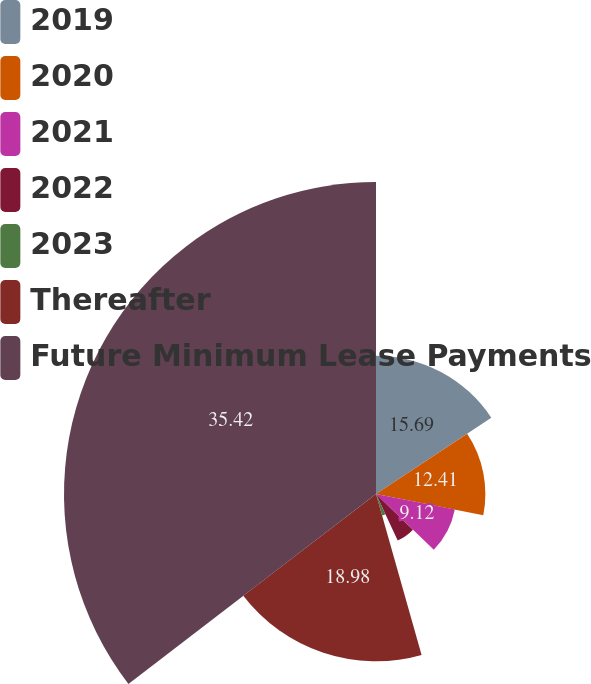Convert chart. <chart><loc_0><loc_0><loc_500><loc_500><pie_chart><fcel>2019<fcel>2020<fcel>2021<fcel>2022<fcel>2023<fcel>Thereafter<fcel>Future Minimum Lease Payments<nl><fcel>15.69%<fcel>12.41%<fcel>9.12%<fcel>5.83%<fcel>2.55%<fcel>18.98%<fcel>35.41%<nl></chart> 